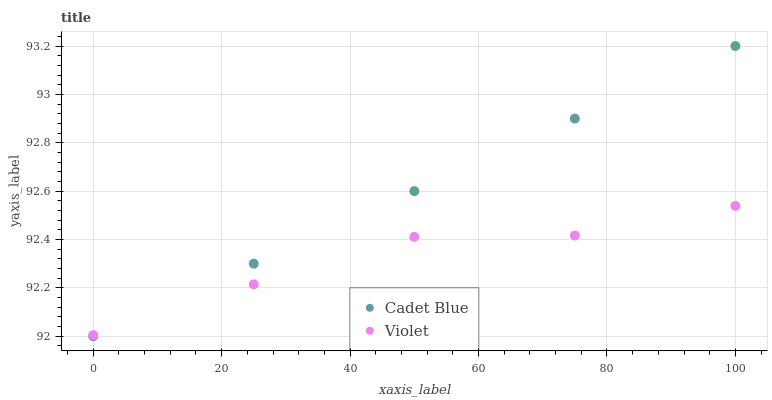Does Violet have the minimum area under the curve?
Answer yes or no. Yes. Does Cadet Blue have the maximum area under the curve?
Answer yes or no. Yes. Does Violet have the maximum area under the curve?
Answer yes or no. No. Is Cadet Blue the smoothest?
Answer yes or no. Yes. Is Violet the roughest?
Answer yes or no. Yes. Is Violet the smoothest?
Answer yes or no. No. Does Cadet Blue have the lowest value?
Answer yes or no. Yes. Does Violet have the lowest value?
Answer yes or no. No. Does Cadet Blue have the highest value?
Answer yes or no. Yes. Does Violet have the highest value?
Answer yes or no. No. Does Cadet Blue intersect Violet?
Answer yes or no. Yes. Is Cadet Blue less than Violet?
Answer yes or no. No. Is Cadet Blue greater than Violet?
Answer yes or no. No. 